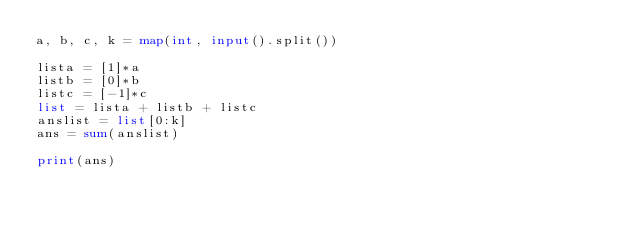Convert code to text. <code><loc_0><loc_0><loc_500><loc_500><_Python_>a, b, c, k = map(int, input().split())

lista = [1]*a
listb = [0]*b
listc = [-1]*c
list = lista + listb + listc
anslist = list[0:k]
ans = sum(anslist)

print(ans)</code> 